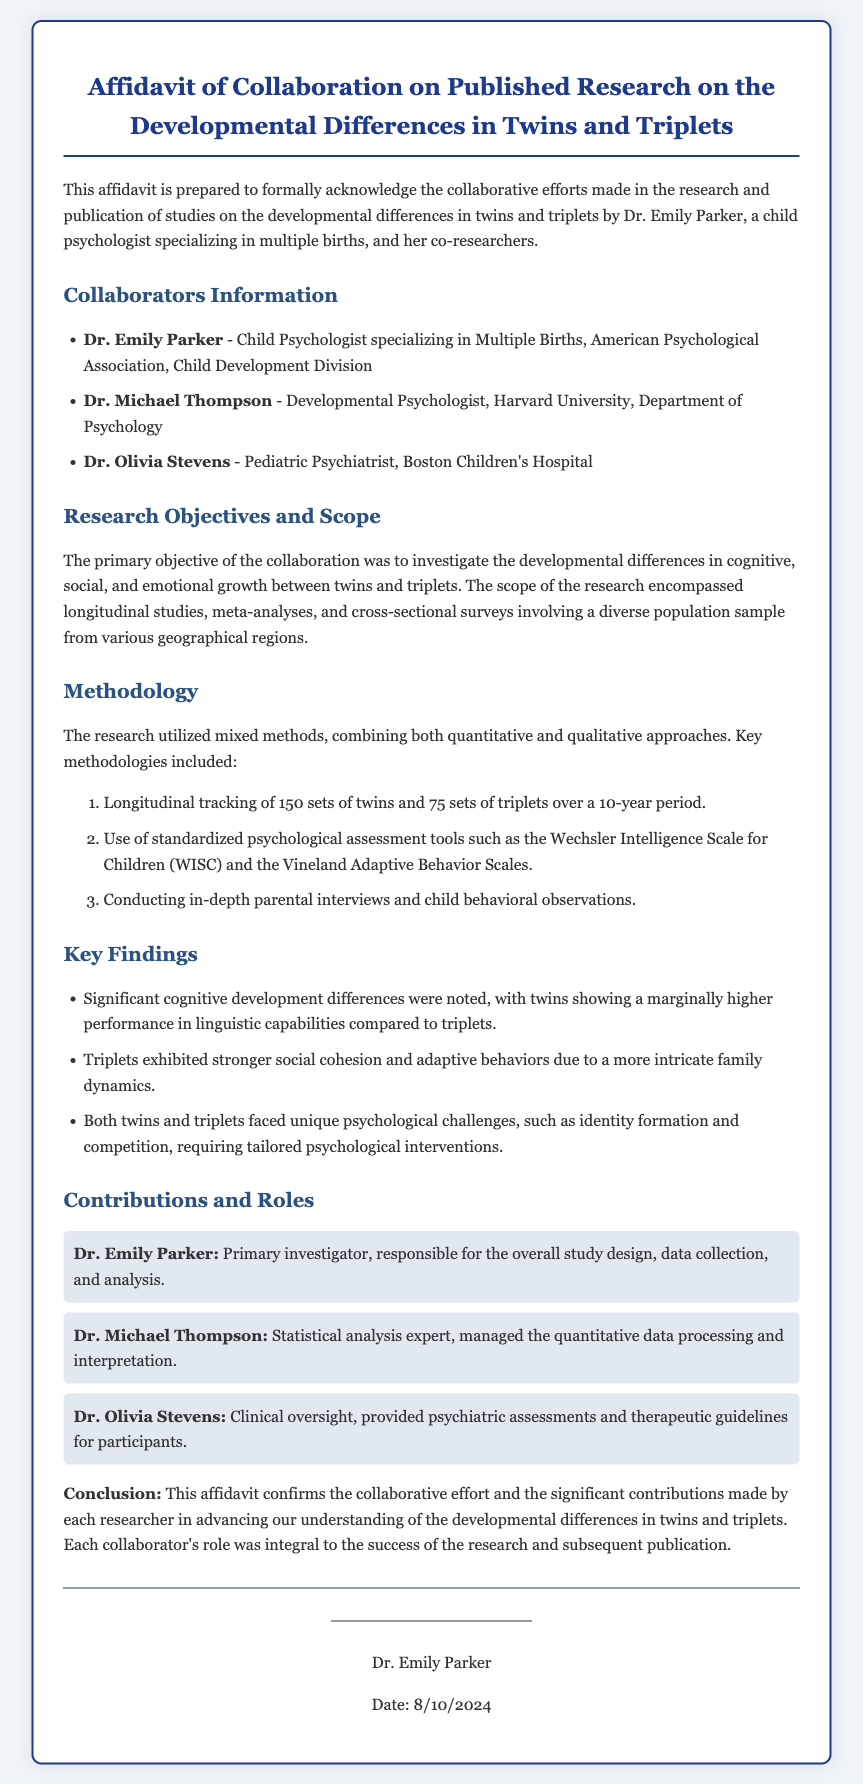what is the title of the document? The title is indicated at the top of the document in a prominent format.
Answer: Affidavit of Collaboration on Published Research on the Developmental Differences in Twins and Triplets who is the primary investigator? The primary investigator's name is listed under the "Contributions and Roles" section.
Answer: Dr. Emily Parker how many sets of twins were tracked in the research? The number of sets of twins is stated in the methodology section, where the research details are outlined.
Answer: 150 sets who conducted the statistical analysis? The collaborator responsible for statistical analysis is mentioned in the contributions section.
Answer: Dr. Michael Thompson what is the main objective of the research collaboration? The primary objective is specified within the "Research Objectives and Scope" section.
Answer: Investigate the developmental differences in cognitive, social, and emotional growth how many sets of triplets were tracked in the research? The document specifies the number of sets of triplets in the methodology section.
Answer: 75 sets what significant finding was noted about twins? One of the key findings regarding twins is listed in the "Key Findings" section.
Answer: Twins showing a marginally higher performance in linguistic capabilities what role did Dr. Olivia Stevens have? The role of Dr. Olivia Stevens is outlined in the "Contributions and Roles" section.
Answer: Clinical oversight what type of methodologies were used in the research? The types of methodologies are described in the methodology section, where detailed methods are listed.
Answer: Mixed methods 